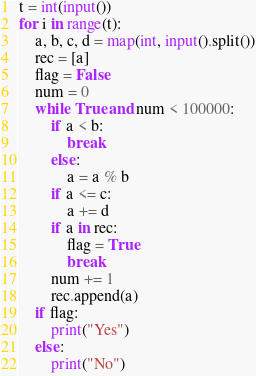Convert code to text. <code><loc_0><loc_0><loc_500><loc_500><_Python_>t = int(input())
for i in range(t):
    a, b, c, d = map(int, input().split())
    rec = [a]
    flag = False
    num = 0
    while True and num < 100000:
        if a < b:
            break
        else:
            a = a % b
        if a <= c:
            a += d
        if a in rec:
            flag = True
            break
        num += 1
        rec.append(a)
    if flag:
        print("Yes")
    else:
        print("No")
</code> 